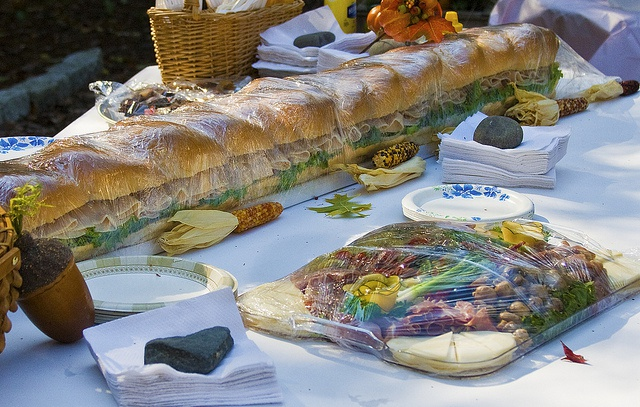Describe the objects in this image and their specific colors. I can see dining table in black, darkgray, lightgray, and gray tones, sandwich in black, olive, gray, and darkgray tones, and potted plant in black, maroon, and olive tones in this image. 